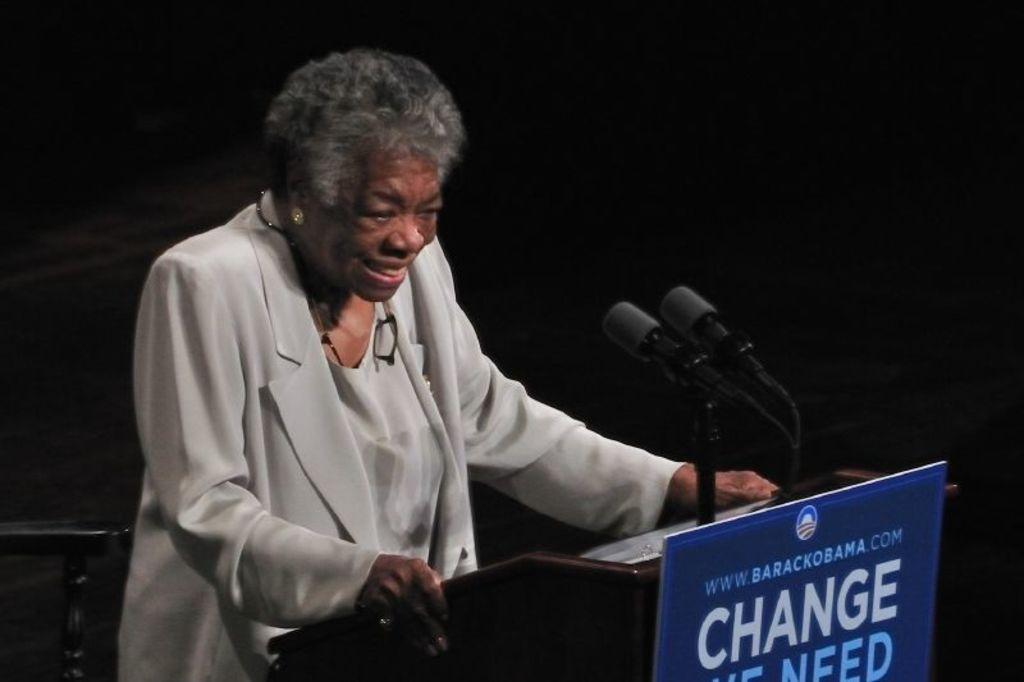What is the person in the image doing near the podium? The person is standing near a podium in the image. What can be seen on the board in the image? The facts provided do not specify what is on the board. What type of animals are present in the image? There are mice in the image. Can you describe the object in the image? The facts provided do not specify what the object is. How would you describe the lighting in the image? The background of the image is dark. How do the ducks interact with the mice in the image? There are no ducks present in the image; only mice are mentioned. What direction are the giants facing in the image? There are no giants present in the image. 